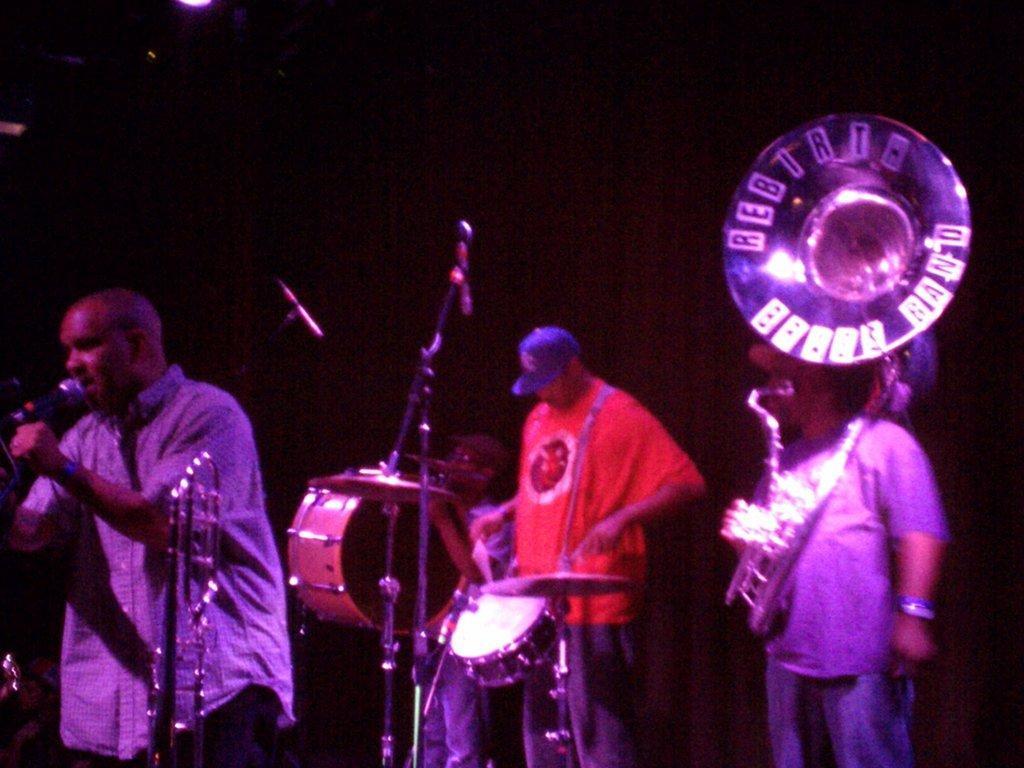In one or two sentences, can you explain what this image depicts? On the left side, there is a person holding a stand, singing and standing in front of a mic which is attached to a stand. On the right side, there are persons in different color dresses, playing musical instruments. In front of them, there is another stand and a musical instrument. In the background, there is a light. And the background is dark in color. 